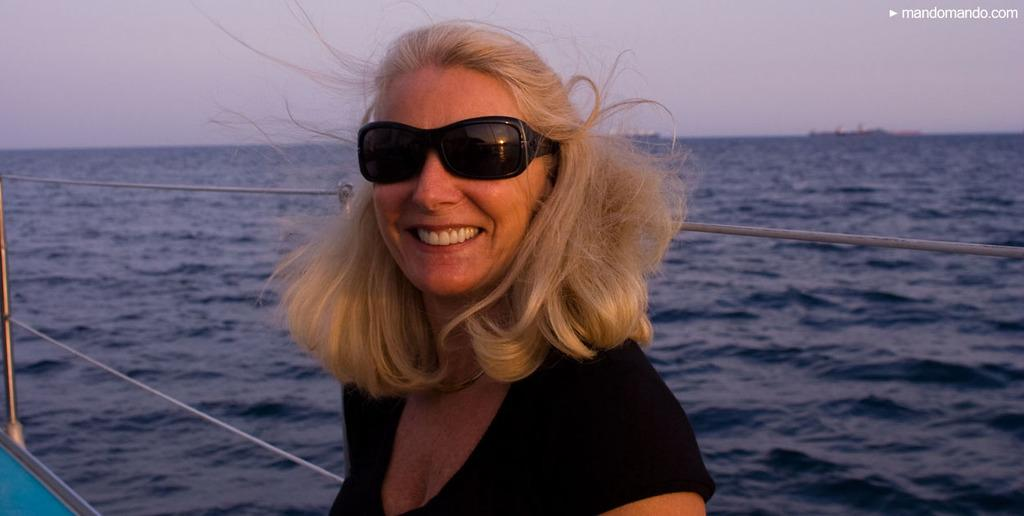What is the main subject of the image? There is a person on a boat in the image. Where is the boat located? The boat is on the water. Can you describe the surrounding environment in the image? There are other boats visible in the background, and the sky is visible in the image. Are there any fairies flying around the boats in the image? There are no fairies present in the image; it only features a person on a boat and other boats in the background. What time of day does the image depict? The provided facts do not mention the time of day, so it cannot be determined from the image. 